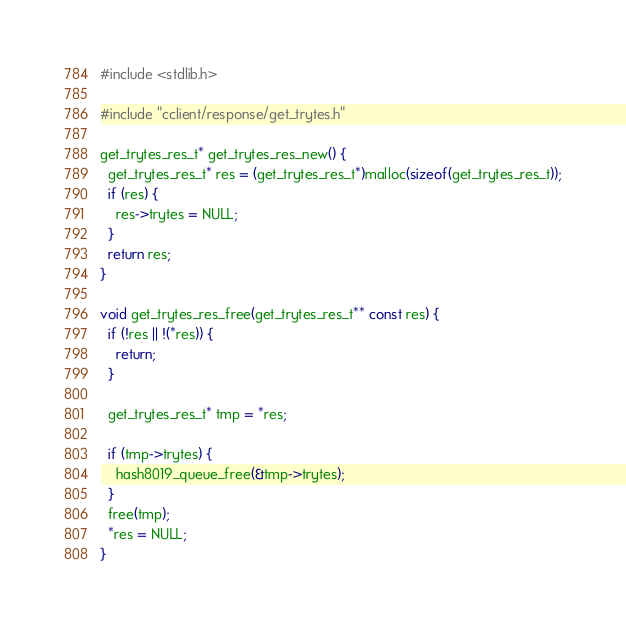<code> <loc_0><loc_0><loc_500><loc_500><_C_>
#include <stdlib.h>

#include "cclient/response/get_trytes.h"

get_trytes_res_t* get_trytes_res_new() {
  get_trytes_res_t* res = (get_trytes_res_t*)malloc(sizeof(get_trytes_res_t));
  if (res) {
    res->trytes = NULL;
  }
  return res;
}

void get_trytes_res_free(get_trytes_res_t** const res) {
  if (!res || !(*res)) {
    return;
  }

  get_trytes_res_t* tmp = *res;

  if (tmp->trytes) {
    hash8019_queue_free(&tmp->trytes);
  }
  free(tmp);
  *res = NULL;
}
</code> 